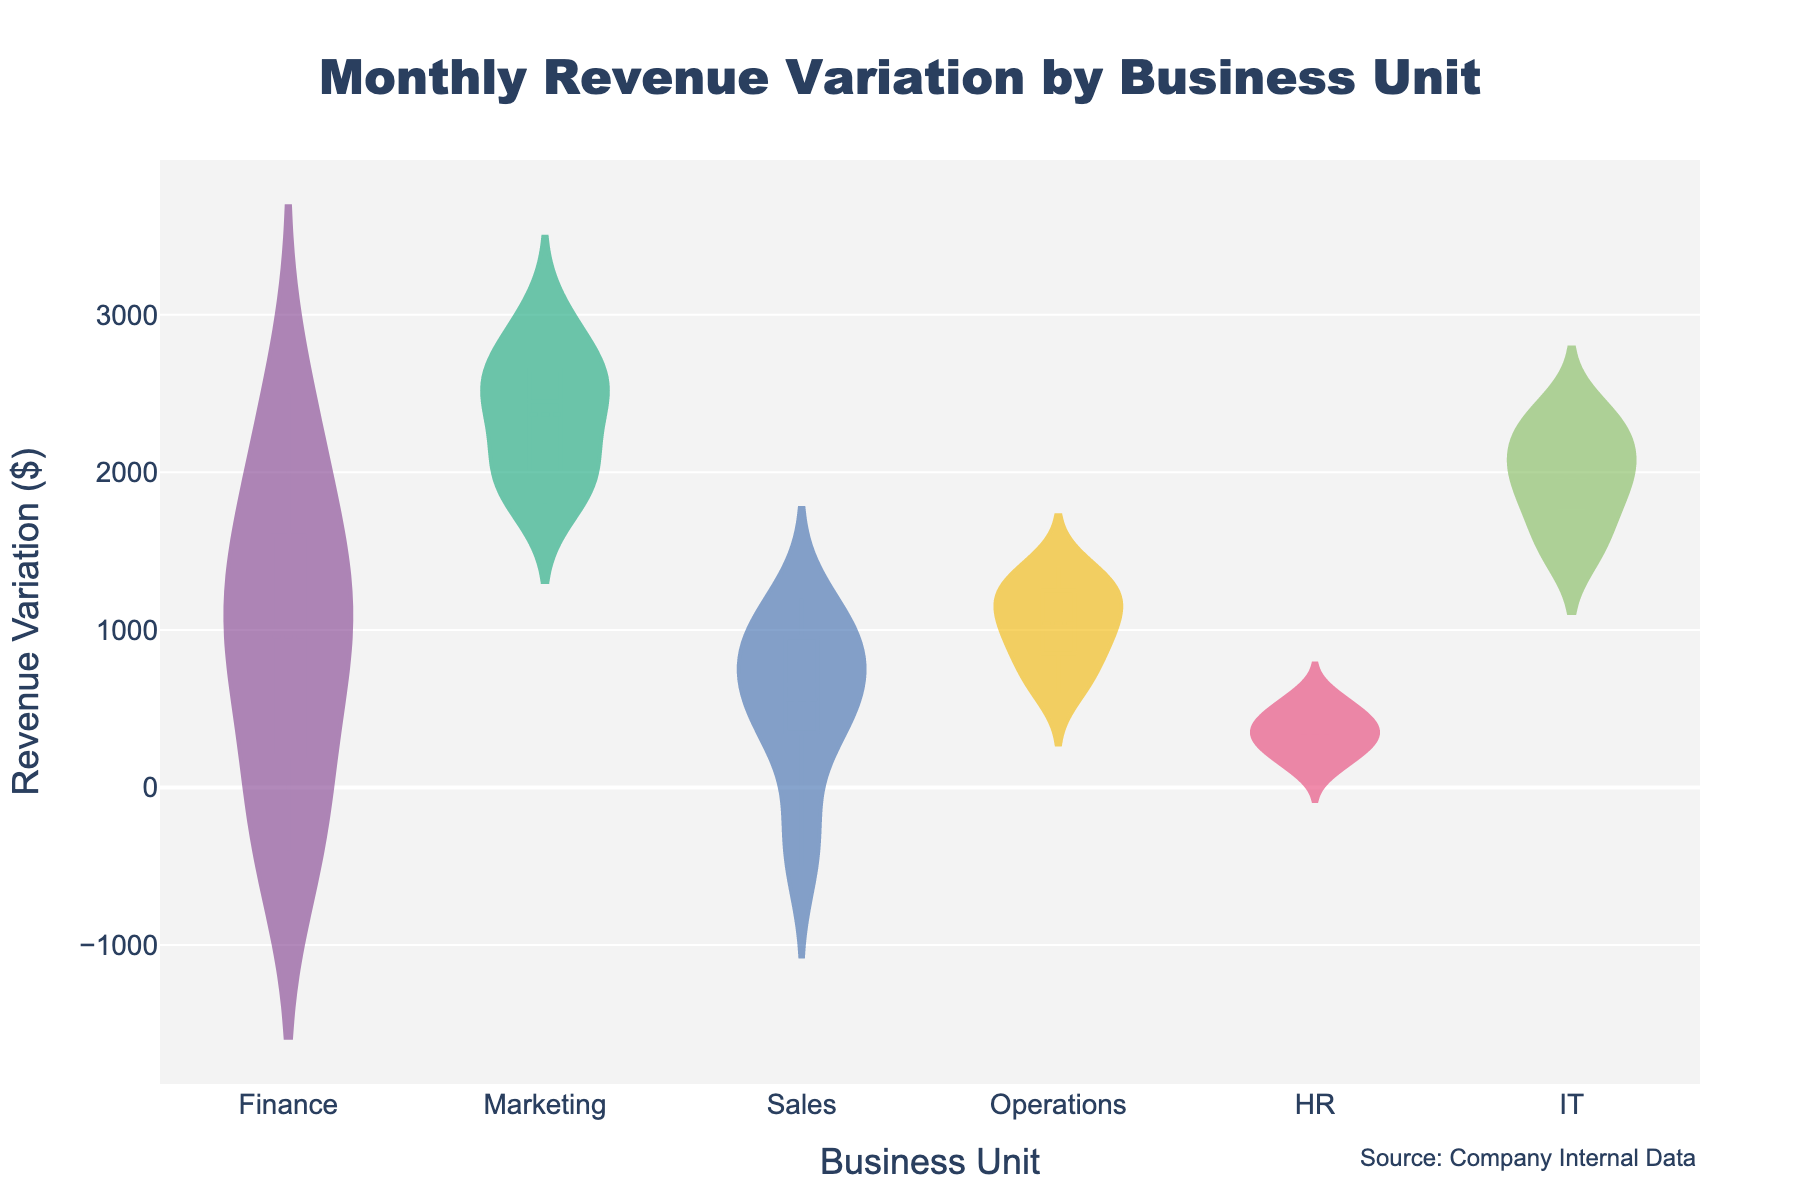What is the title of the figure? The title of the figure is usually located at the top center and it often describes the primary focus of the visual representation. In this case, the title of the figure is "Monthly Revenue Variation by Business Unit."
Answer: Monthly Revenue Variation by Business Unit How many business units are displayed in the figure? The number of distinct violin plots represents the number of business units. By examining the x-axis labels, we see there are six different business units: Finance, Marketing, Sales, Operations, HR, and IT.
Answer: Six Which business unit has the highest mean revenue variation? For each violin plot, a horizontal line typically represents the mean. By comparing the positions of these lines across all business units, the highest mean can be identified. The Marketing unit has a mean line higher than all other units.
Answer: Marketing What is the range of revenue variation for the HR unit? The range is determined by the highest and lowest points of the violin plot for the HR unit. By observing the points on the y-axis that the HR unit spans, it starts around 100 and ends around 600, so the range is 600 - 100 = 500.
Answer: 500 Which business unit displays the widest distribution in revenue variation? The width of the violin plots indicates the distribution spread. By comparing all units, Finance shows a distribution with significant spread covering both positive and negative variations, indicating it has the widest distribution.
Answer: Finance What is the median revenue variation of the IT unit? The median is generally represented by a marker inside the violin plot. By locating the median marker inside the IT unit's violin plot, it is roughly at 2000.
Answer: 2000 Do any of the business units have a negative revenue variation? If so, which? Negative revenue variations are indicated by any part of the violin plot dipping below the zero line on the y-axis. Finance and Sales units have sections below zero, indicating negative variations.
Answer: Finance, Sales How does the revenue variation of the Marketing unit compare with the HR unit? By comparing the shapes and positions of the violin plots for Marketing and HR, Marketing displays a higher mean, higher median, and larger overall spread indicating typically higher revenue variations compared to HR.
Answer: Marketing shows higher revenue variations than HR Which business unit has the smallest variation in their revenue? The smallest variation is identified by the smallest width and range of the violin plot. HR shows a relatively narrow and tight distribution compared to other units, indicating the smallest variation.
Answer: HR What is the interquartile range (IQR) for the Sales unit? The IQR can be found by determining the range between the first quartile (Q1) and the third quartile (Q3) within the Sales unit's violin plot. Q1 is around 300 and Q3 is around 900, so the IQR is 900 - 300 = 600.
Answer: 600 